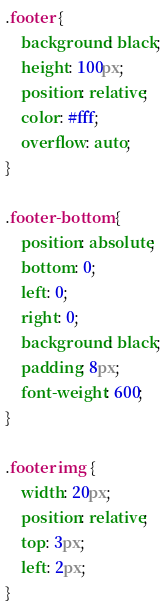Convert code to text. <code><loc_0><loc_0><loc_500><loc_500><_CSS_>.footer {
    background: black;
    height: 100px;
    position: relative;
    color: #fff;
    overflow: auto;
}

.footer-bottom {
    position: absolute;
    bottom: 0;
    left: 0;
    right: 0;
    background: black;
    padding: 8px;
    font-weight: 600;
}

.footer img {
    width: 20px;
    position: relative;
    top: 3px;
    left: 2px;
}</code> 